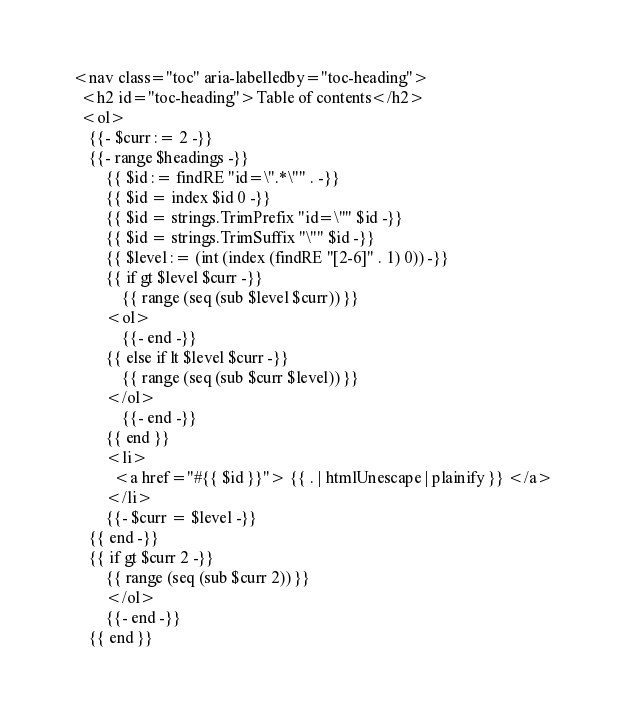Convert code to text. <code><loc_0><loc_0><loc_500><loc_500><_HTML_>  <nav class="toc" aria-labelledby="toc-heading">
    <h2 id="toc-heading">Table of contents</h2>
    <ol>
      {{- $curr := 2 -}}
      {{- range $headings -}}
          {{ $id := findRE "id=\".*\"" . -}}
          {{ $id = index $id 0 -}}
          {{ $id = strings.TrimPrefix "id=\"" $id -}}
          {{ $id = strings.TrimSuffix "\"" $id -}}
          {{ $level := (int (index (findRE "[2-6]" . 1) 0)) -}}
          {{ if gt $level $curr -}}
              {{ range (seq (sub $level $curr)) }}
          <ol>
              {{- end -}}
          {{ else if lt $level $curr -}}
              {{ range (seq (sub $curr $level)) }}
          </ol>
              {{- end -}}
          {{ end }}
          <li>
            <a href="#{{ $id }}"> {{ . | htmlUnescape | plainify }} </a>
          </li>
          {{- $curr = $level -}}
      {{ end -}}
      {{ if gt $curr 2 -}}
          {{ range (seq (sub $curr 2)) }}
          </ol>
          {{- end -}}
      {{ end }}</code> 